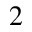Convert formula to latex. <formula><loc_0><loc_0><loc_500><loc_500>2</formula> 